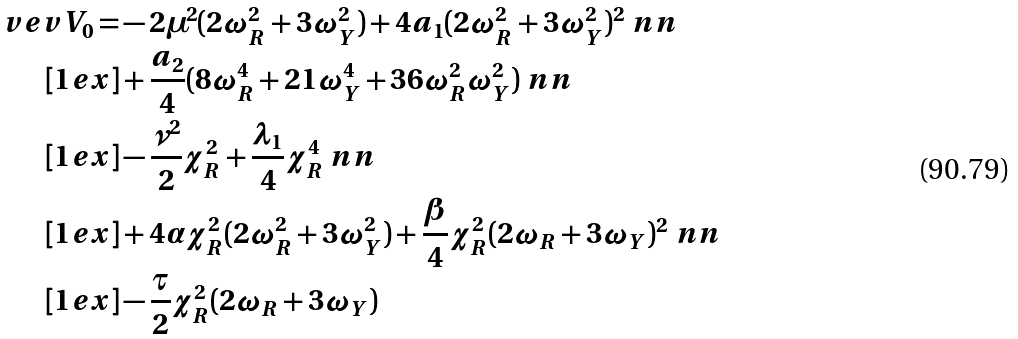Convert formula to latex. <formula><loc_0><loc_0><loc_500><loc_500>\ v e v { V _ { 0 } } = & - 2 \mu ^ { 2 } ( 2 \omega _ { R } ^ { 2 } + 3 \omega _ { Y } ^ { 2 } ) + 4 a _ { 1 } ( 2 \omega _ { R } ^ { 2 } + 3 \omega _ { Y } ^ { 2 } ) ^ { 2 } \ n n \\ [ 1 e x ] & + \frac { a _ { 2 } } { 4 } ( 8 \omega _ { R } ^ { 4 } + 2 1 \omega _ { Y } ^ { 4 } + 3 6 \omega _ { R } ^ { 2 } \omega _ { Y } ^ { 2 } ) \ n n \\ [ 1 e x ] & - \frac { \nu ^ { 2 } } { 2 } \chi _ { R } ^ { 2 } + \frac { \lambda _ { 1 } } { 4 } \chi _ { R } ^ { 4 } \ n n \\ [ 1 e x ] & + 4 \alpha \chi _ { R } ^ { 2 } ( 2 \omega _ { R } ^ { 2 } + 3 \omega _ { Y } ^ { 2 } ) + \frac { \beta } { 4 } \chi _ { R } ^ { 2 } ( 2 \omega _ { R } + 3 \omega _ { Y } ) ^ { 2 } \ n n \\ [ 1 e x ] & - \frac { \tau } { 2 } \chi _ { R } ^ { 2 } ( 2 \omega _ { R } + 3 \omega _ { Y } )</formula> 